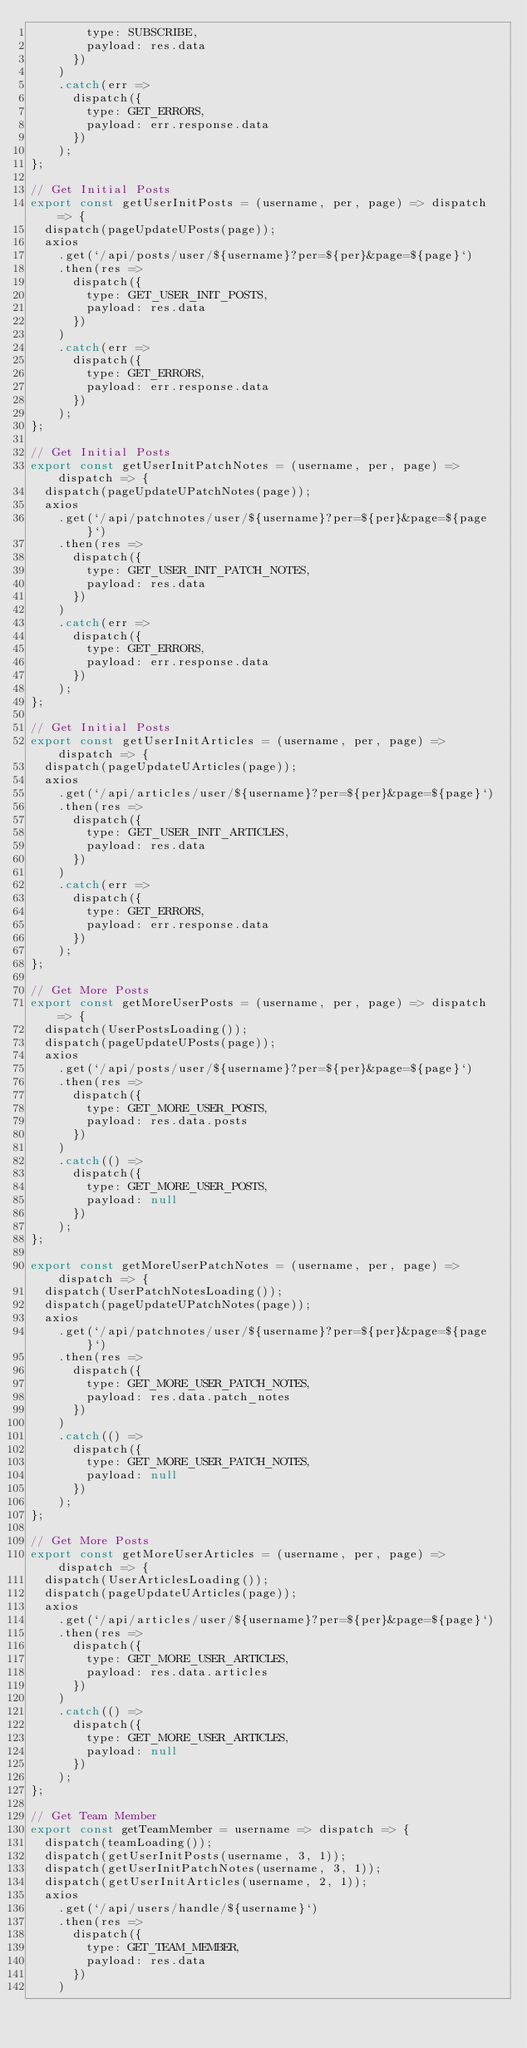Convert code to text. <code><loc_0><loc_0><loc_500><loc_500><_JavaScript_>        type: SUBSCRIBE,
        payload: res.data
      })
    )
    .catch(err =>
      dispatch({
        type: GET_ERRORS,
        payload: err.response.data
      })
    );
};

// Get Initial Posts
export const getUserInitPosts = (username, per, page) => dispatch => {
  dispatch(pageUpdateUPosts(page));
  axios
    .get(`/api/posts/user/${username}?per=${per}&page=${page}`)
    .then(res =>
      dispatch({
        type: GET_USER_INIT_POSTS,
        payload: res.data
      })
    )
    .catch(err =>
      dispatch({
        type: GET_ERRORS,
        payload: err.response.data
      })
    );
};

// Get Initial Posts
export const getUserInitPatchNotes = (username, per, page) => dispatch => {
  dispatch(pageUpdateUPatchNotes(page));
  axios
    .get(`/api/patchnotes/user/${username}?per=${per}&page=${page}`)
    .then(res =>
      dispatch({
        type: GET_USER_INIT_PATCH_NOTES,
        payload: res.data
      })
    )
    .catch(err =>
      dispatch({
        type: GET_ERRORS,
        payload: err.response.data
      })
    );
};

// Get Initial Posts
export const getUserInitArticles = (username, per, page) => dispatch => {
  dispatch(pageUpdateUArticles(page));
  axios
    .get(`/api/articles/user/${username}?per=${per}&page=${page}`)
    .then(res =>
      dispatch({
        type: GET_USER_INIT_ARTICLES,
        payload: res.data
      })
    )
    .catch(err =>
      dispatch({
        type: GET_ERRORS,
        payload: err.response.data
      })
    );
};

// Get More Posts
export const getMoreUserPosts = (username, per, page) => dispatch => {
  dispatch(UserPostsLoading());
  dispatch(pageUpdateUPosts(page));
  axios
    .get(`/api/posts/user/${username}?per=${per}&page=${page}`)
    .then(res =>
      dispatch({
        type: GET_MORE_USER_POSTS,
        payload: res.data.posts
      })
    )
    .catch(() =>
      dispatch({
        type: GET_MORE_USER_POSTS,
        payload: null
      })
    );
};

export const getMoreUserPatchNotes = (username, per, page) => dispatch => {
  dispatch(UserPatchNotesLoading());
  dispatch(pageUpdateUPatchNotes(page));
  axios
    .get(`/api/patchnotes/user/${username}?per=${per}&page=${page}`)
    .then(res =>
      dispatch({
        type: GET_MORE_USER_PATCH_NOTES,
        payload: res.data.patch_notes
      })
    )
    .catch(() =>
      dispatch({
        type: GET_MORE_USER_PATCH_NOTES,
        payload: null
      })
    );
};

// Get More Posts
export const getMoreUserArticles = (username, per, page) => dispatch => {
  dispatch(UserArticlesLoading());
  dispatch(pageUpdateUArticles(page));
  axios
    .get(`/api/articles/user/${username}?per=${per}&page=${page}`)
    .then(res =>
      dispatch({
        type: GET_MORE_USER_ARTICLES,
        payload: res.data.articles
      })
    )
    .catch(() =>
      dispatch({
        type: GET_MORE_USER_ARTICLES,
        payload: null
      })
    );
};

// Get Team Member
export const getTeamMember = username => dispatch => {
  dispatch(teamLoading());
  dispatch(getUserInitPosts(username, 3, 1));
  dispatch(getUserInitPatchNotes(username, 3, 1));
  dispatch(getUserInitArticles(username, 2, 1));
  axios
    .get(`/api/users/handle/${username}`)
    .then(res =>
      dispatch({
        type: GET_TEAM_MEMBER,
        payload: res.data
      })
    )</code> 